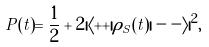<formula> <loc_0><loc_0><loc_500><loc_500>P ( t ) = \frac { 1 } { 2 } + 2 | \langle + + | \rho _ { S } ( t ) | - - \rangle | ^ { 2 } ,</formula> 